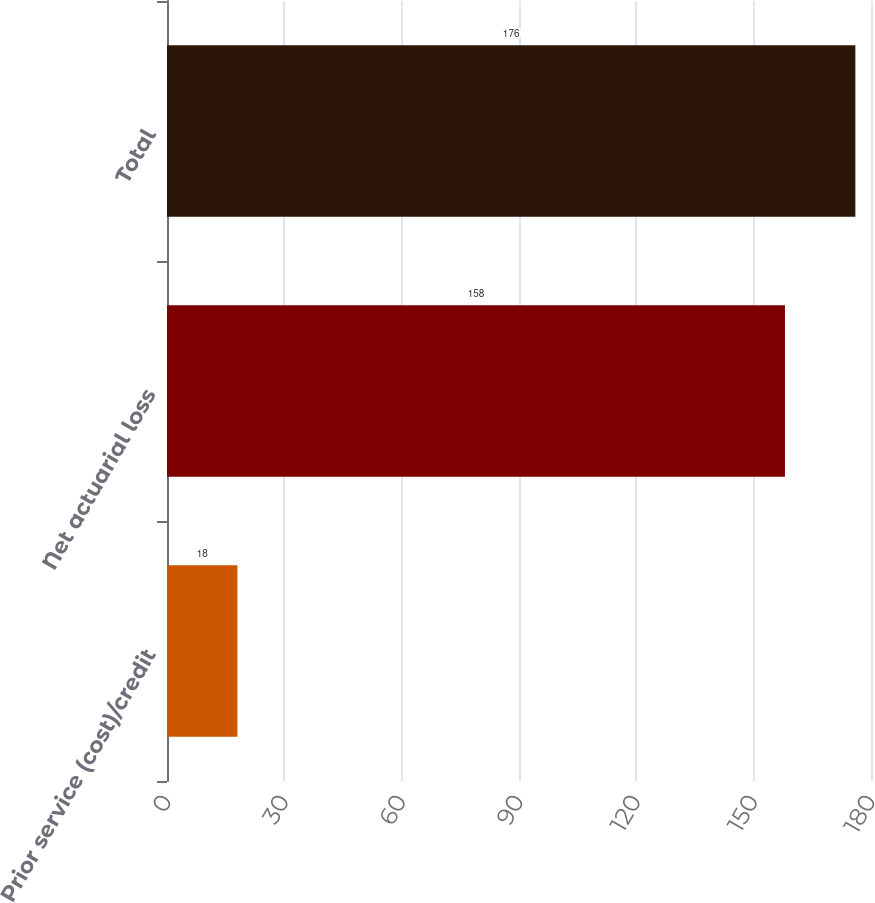Convert chart. <chart><loc_0><loc_0><loc_500><loc_500><bar_chart><fcel>Prior service (cost)/credit<fcel>Net actuarial loss<fcel>Total<nl><fcel>18<fcel>158<fcel>176<nl></chart> 